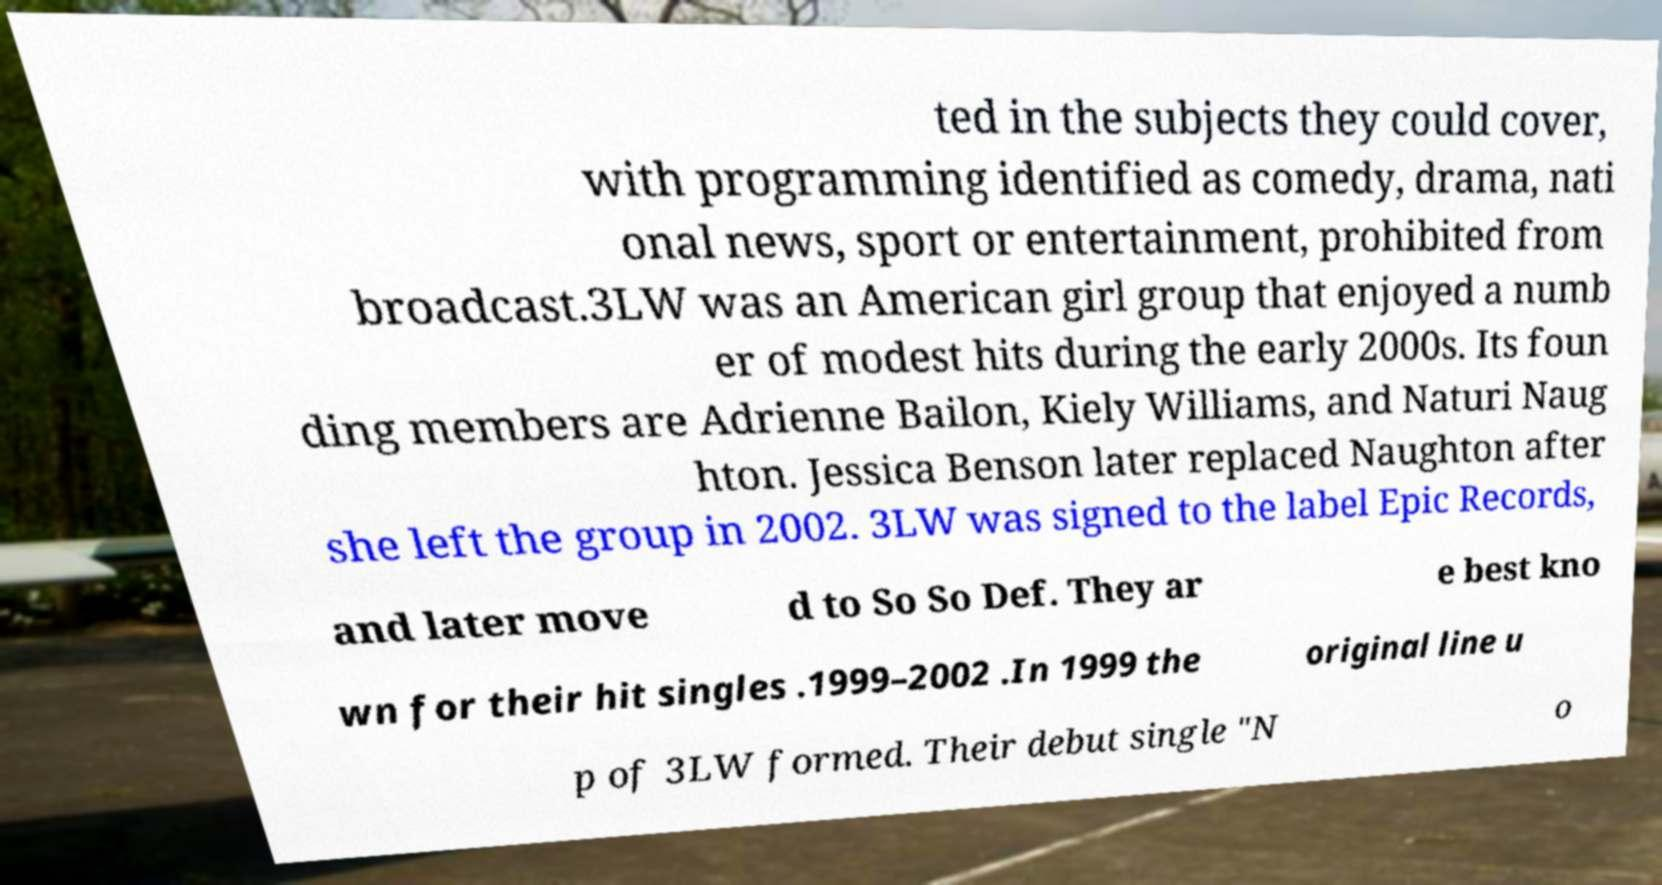Could you assist in decoding the text presented in this image and type it out clearly? ted in the subjects they could cover, with programming identified as comedy, drama, nati onal news, sport or entertainment, prohibited from broadcast.3LW was an American girl group that enjoyed a numb er of modest hits during the early 2000s. Its foun ding members are Adrienne Bailon, Kiely Williams, and Naturi Naug hton. Jessica Benson later replaced Naughton after she left the group in 2002. 3LW was signed to the label Epic Records, and later move d to So So Def. They ar e best kno wn for their hit singles .1999–2002 .In 1999 the original line u p of 3LW formed. Their debut single "N o 